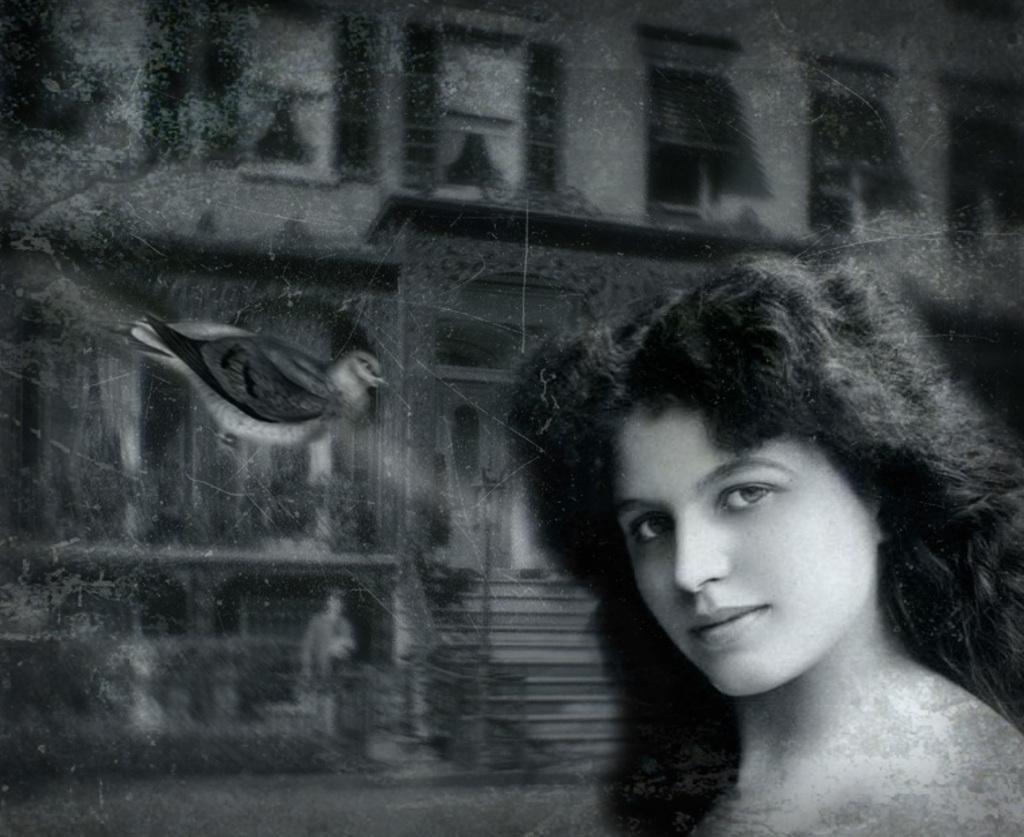Could you give a brief overview of what you see in this image? In this picture there is a edited image of the girl, in the front smiling and giving a pose into the camera. Behind there is a bird flying in the air and a old building. 